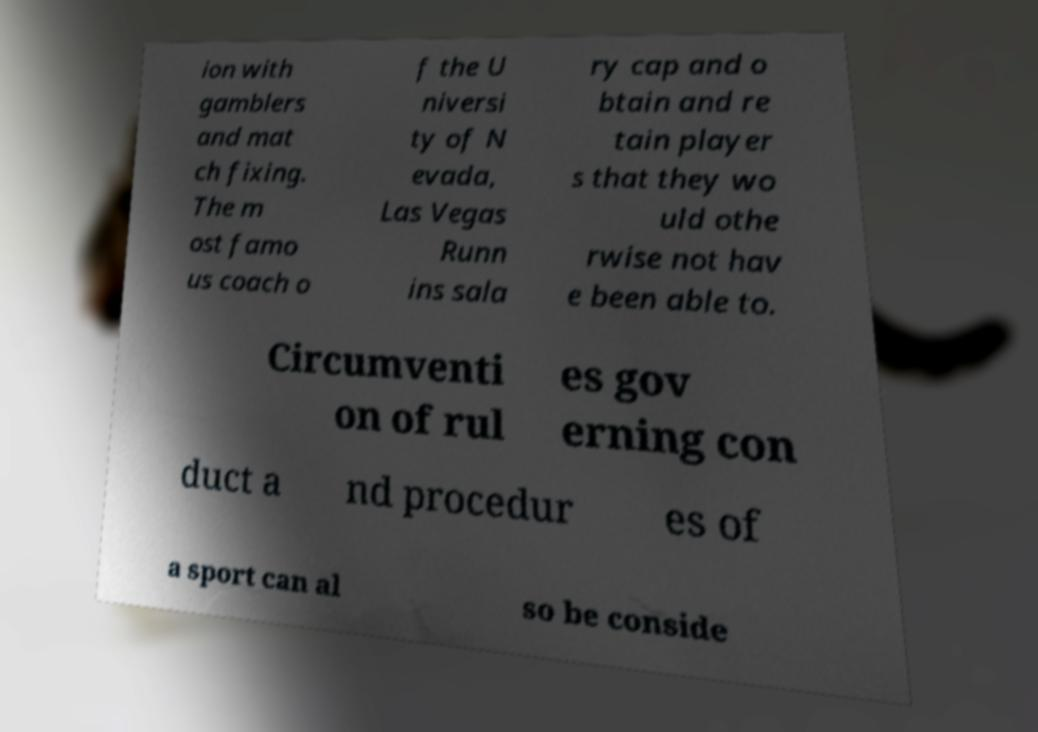Please read and relay the text visible in this image. What does it say? ion with gamblers and mat ch fixing. The m ost famo us coach o f the U niversi ty of N evada, Las Vegas Runn ins sala ry cap and o btain and re tain player s that they wo uld othe rwise not hav e been able to. Circumventi on of rul es gov erning con duct a nd procedur es of a sport can al so be conside 